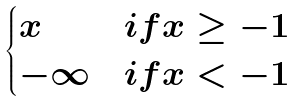<formula> <loc_0><loc_0><loc_500><loc_500>\begin{cases} x & i f x \geq - 1 \\ - \infty & i f x < - 1 \end{cases}</formula> 